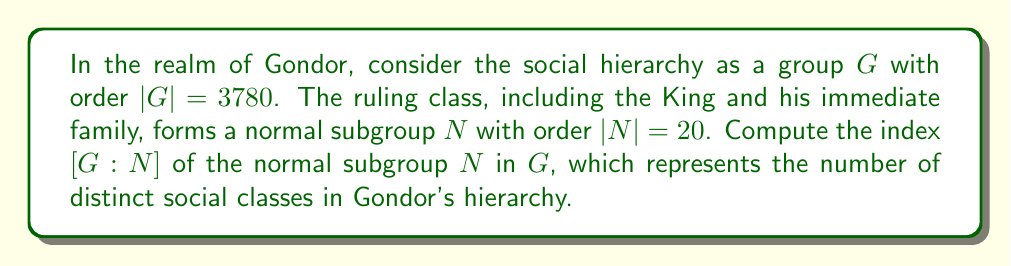Help me with this question. To solve this problem, we'll use the fundamental theorem of group theory that relates the order of a group, the order of a subgroup, and the index of that subgroup.

1) The index of a subgroup $N$ in a group $G$, denoted $[G:N]$, is defined as the number of distinct left (or right) cosets of $N$ in $G$.

2) The Lagrange's theorem states that for a finite group $G$ and a subgroup $N$:

   $$|G| = |N| \cdot [G:N]$$

3) In this case, we are given:
   - $|G| = 3780$ (the order of the entire social hierarchy)
   - $|N| = 20$ (the order of the ruling class subgroup)

4) To find $[G:N]$, we can rearrange the equation from Lagrange's theorem:

   $$[G:N] = \frac{|G|}{|N|}$$

5) Substituting the given values:

   $$[G:N] = \frac{3780}{20}$$

6) Simplifying:
   
   $$[G:N] = 189$$

Therefore, the index $[G:N]$ is 189, representing 189 distinct social classes in Gondor's hierarchy.
Answer: $[G:N] = 189$ 